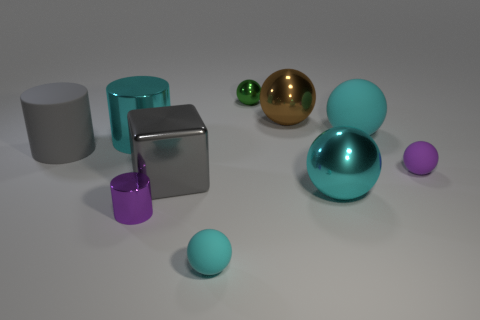How many balls are both left of the small purple rubber sphere and in front of the large gray matte cylinder?
Your answer should be compact. 2. What material is the big cyan ball behind the big cyan metallic thing that is to the left of the block?
Your response must be concise. Rubber. What material is the tiny object that is the same shape as the large gray rubber thing?
Make the answer very short. Metal. Is there a big block?
Make the answer very short. Yes. There is a big gray object that is made of the same material as the big brown object; what shape is it?
Ensure brevity in your answer.  Cube. There is a cyan sphere that is to the left of the large cyan shiny ball; what material is it?
Make the answer very short. Rubber. There is a shiny ball that is in front of the brown metallic object; is it the same color as the big block?
Provide a short and direct response. No. What size is the cyan rubber sphere that is in front of the big sphere in front of the big cyan cylinder?
Your answer should be compact. Small. Is the number of tiny metal things that are on the right side of the large brown shiny thing greater than the number of gray metallic blocks?
Offer a terse response. No. Are there an equal number of gray matte objects and yellow shiny cylinders?
Keep it short and to the point. No. 